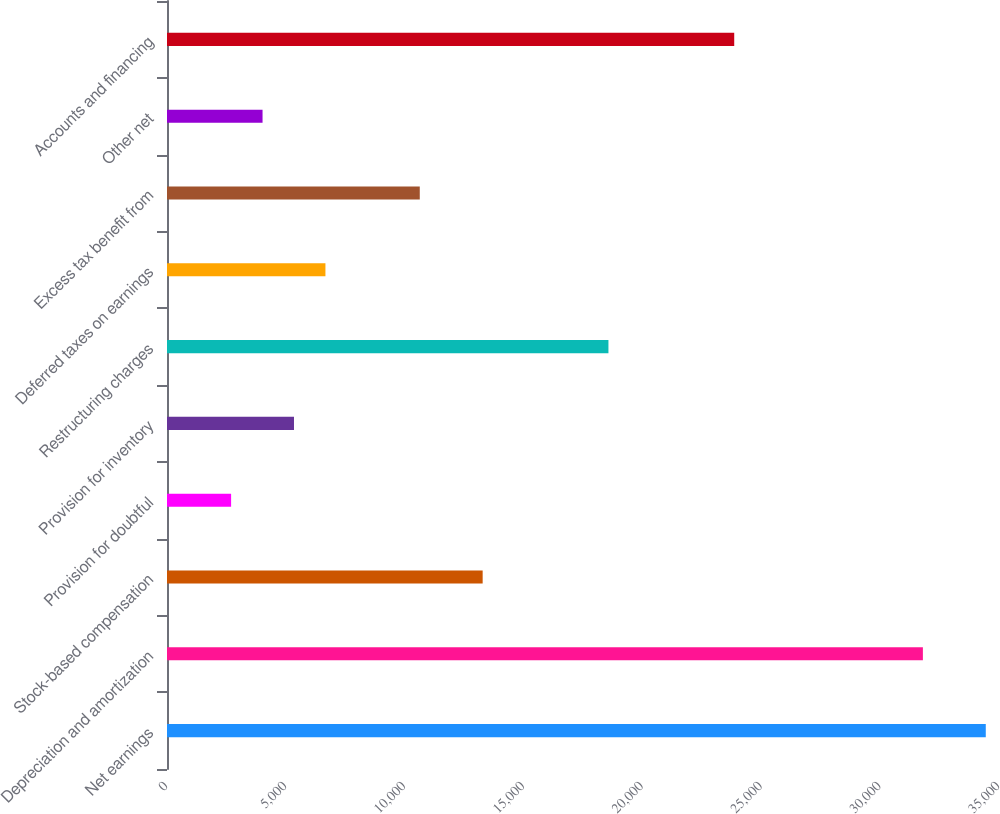Convert chart. <chart><loc_0><loc_0><loc_500><loc_500><bar_chart><fcel>Net earnings<fcel>Depreciation and amortization<fcel>Stock-based compensation<fcel>Provision for doubtful<fcel>Provision for inventory<fcel>Restructuring charges<fcel>Deferred taxes on earnings<fcel>Excess tax benefit from<fcel>Other net<fcel>Accounts and financing<nl><fcel>34443.8<fcel>31798.2<fcel>13279<fcel>2696.6<fcel>5342.2<fcel>18570.2<fcel>6665<fcel>10633.4<fcel>4019.4<fcel>23861.4<nl></chart> 